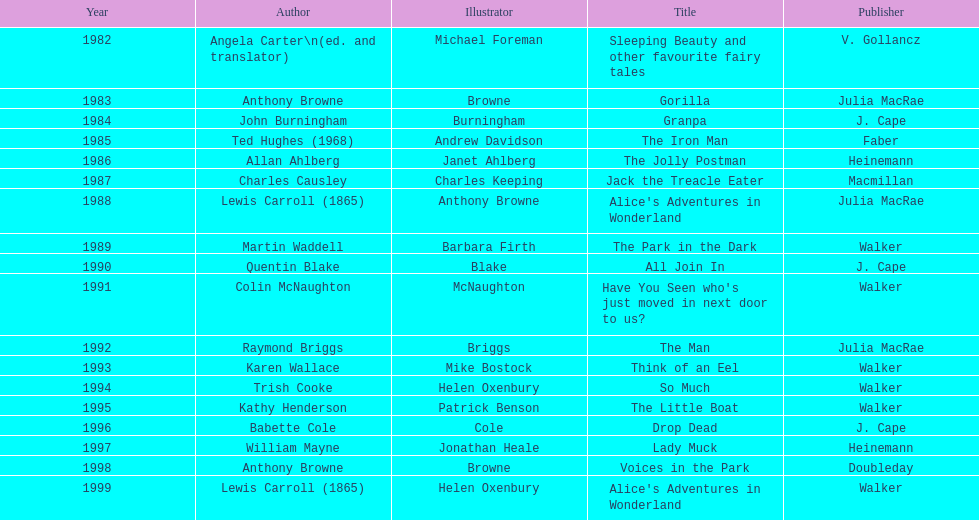Which title was after the year 1991 but before the year 1993? The Man. 